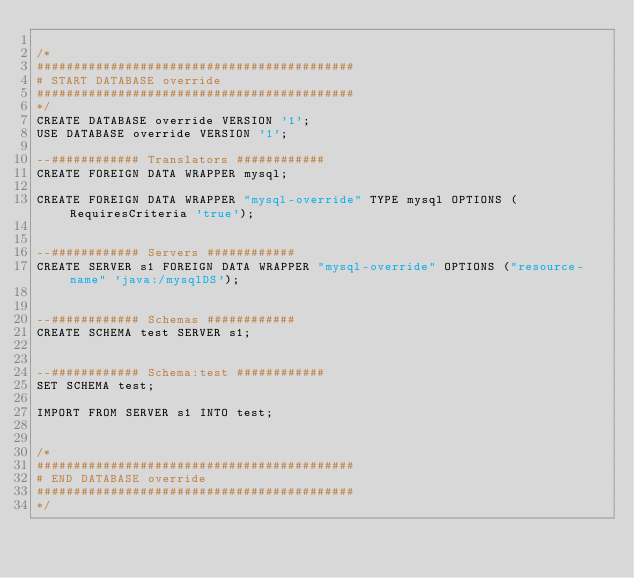Convert code to text. <code><loc_0><loc_0><loc_500><loc_500><_SQL_>
/*
###########################################
# START DATABASE override
###########################################
*/
CREATE DATABASE override VERSION '1';
USE DATABASE override VERSION '1';

--############ Translators ############
CREATE FOREIGN DATA WRAPPER mysql;

CREATE FOREIGN DATA WRAPPER "mysql-override" TYPE mysql OPTIONS (RequiresCriteria 'true');


--############ Servers ############
CREATE SERVER s1 FOREIGN DATA WRAPPER "mysql-override" OPTIONS ("resource-name" 'java:/mysqlDS');


--############ Schemas ############
CREATE SCHEMA test SERVER s1;


--############ Schema:test ############
SET SCHEMA test;

IMPORT FROM SERVER s1 INTO test;


/*
###########################################
# END DATABASE override
###########################################
*/

</code> 